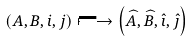<formula> <loc_0><loc_0><loc_500><loc_500>( A , B , i , j ) \longmapsto \left ( \widehat { A } , \widehat { B } , \hat { \imath } , \hat { \jmath } \right )</formula> 